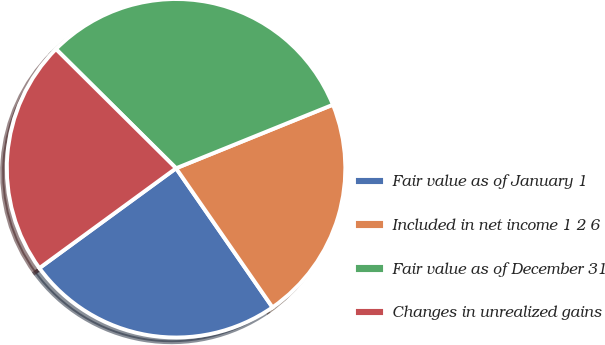Convert chart to OTSL. <chart><loc_0><loc_0><loc_500><loc_500><pie_chart><fcel>Fair value as of January 1<fcel>Included in net income 1 2 6<fcel>Fair value as of December 31<fcel>Changes in unrealized gains<nl><fcel>24.61%<fcel>21.48%<fcel>31.44%<fcel>22.48%<nl></chart> 